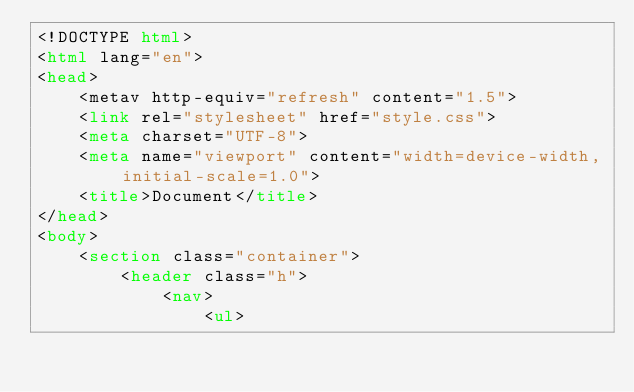<code> <loc_0><loc_0><loc_500><loc_500><_HTML_><!DOCTYPE html>
<html lang="en">
<head>
    <metav http-equiv="refresh" content="1.5">
    <link rel="stylesheet" href="style.css">
    <meta charset="UTF-8">
    <meta name="viewport" content="width=device-width, initial-scale=1.0">
    <title>Document</title>
</head>
<body>
    <section class="container">
        <header class="h">
            <nav>
                <ul></code> 